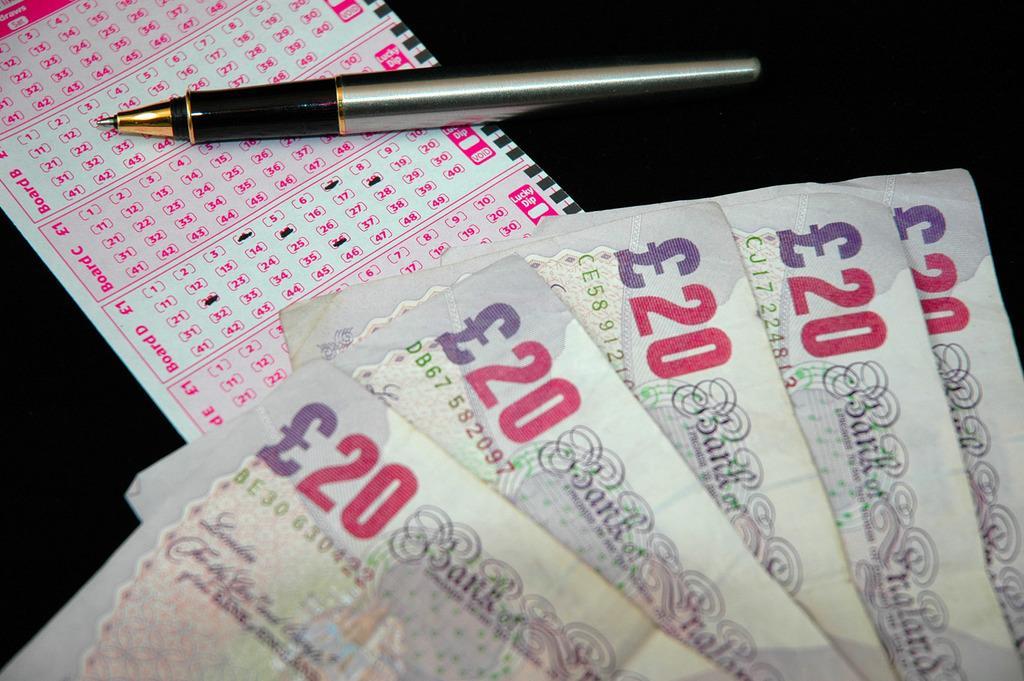In one or two sentences, can you explain what this image depicts? It is a zoom in picture of five notes, a pen and also an omr sheet on the black surface. 